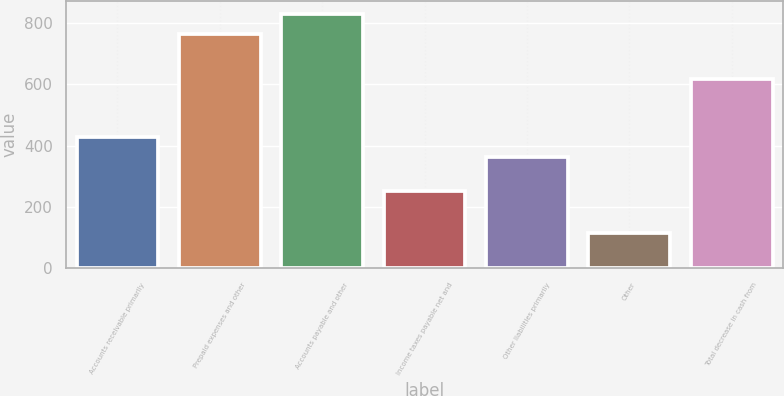Convert chart. <chart><loc_0><loc_0><loc_500><loc_500><bar_chart><fcel>Accounts receivable primarily<fcel>Prepaid expenses and other<fcel>Accounts payable and other<fcel>Income taxes payable net and<fcel>Other liabilities primarily<fcel>Other<fcel>Total decrease in cash from<nl><fcel>428.9<fcel>763<fcel>829.9<fcel>252<fcel>362<fcel>114<fcel>618<nl></chart> 